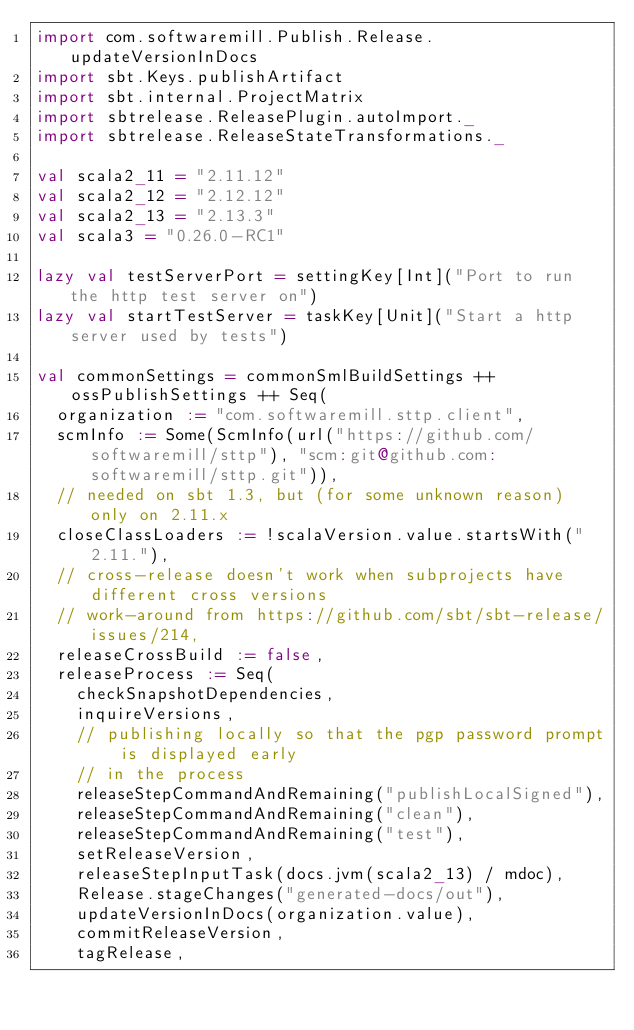<code> <loc_0><loc_0><loc_500><loc_500><_Scala_>import com.softwaremill.Publish.Release.updateVersionInDocs
import sbt.Keys.publishArtifact
import sbt.internal.ProjectMatrix
import sbtrelease.ReleasePlugin.autoImport._
import sbtrelease.ReleaseStateTransformations._

val scala2_11 = "2.11.12"
val scala2_12 = "2.12.12"
val scala2_13 = "2.13.3"
val scala3 = "0.26.0-RC1"

lazy val testServerPort = settingKey[Int]("Port to run the http test server on")
lazy val startTestServer = taskKey[Unit]("Start a http server used by tests")

val commonSettings = commonSmlBuildSettings ++ ossPublishSettings ++ Seq(
  organization := "com.softwaremill.sttp.client",
  scmInfo := Some(ScmInfo(url("https://github.com/softwaremill/sttp"), "scm:git@github.com:softwaremill/sttp.git")),
  // needed on sbt 1.3, but (for some unknown reason) only on 2.11.x
  closeClassLoaders := !scalaVersion.value.startsWith("2.11."),
  // cross-release doesn't work when subprojects have different cross versions
  // work-around from https://github.com/sbt/sbt-release/issues/214,
  releaseCrossBuild := false,
  releaseProcess := Seq(
    checkSnapshotDependencies,
    inquireVersions,
    // publishing locally so that the pgp password prompt is displayed early
    // in the process
    releaseStepCommandAndRemaining("publishLocalSigned"),
    releaseStepCommandAndRemaining("clean"),
    releaseStepCommandAndRemaining("test"),
    setReleaseVersion,
    releaseStepInputTask(docs.jvm(scala2_13) / mdoc),
    Release.stageChanges("generated-docs/out"),
    updateVersionInDocs(organization.value),
    commitReleaseVersion,
    tagRelease,</code> 